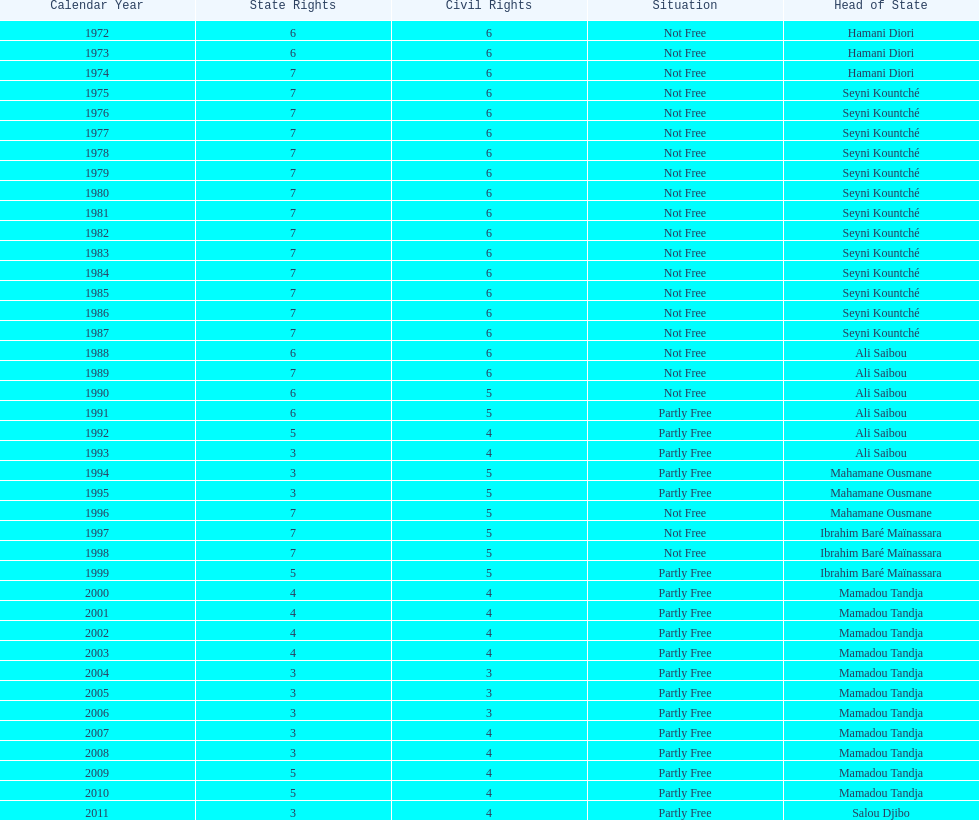Who ruled longer, ali saibou or mamadou tandja? Mamadou Tandja. 